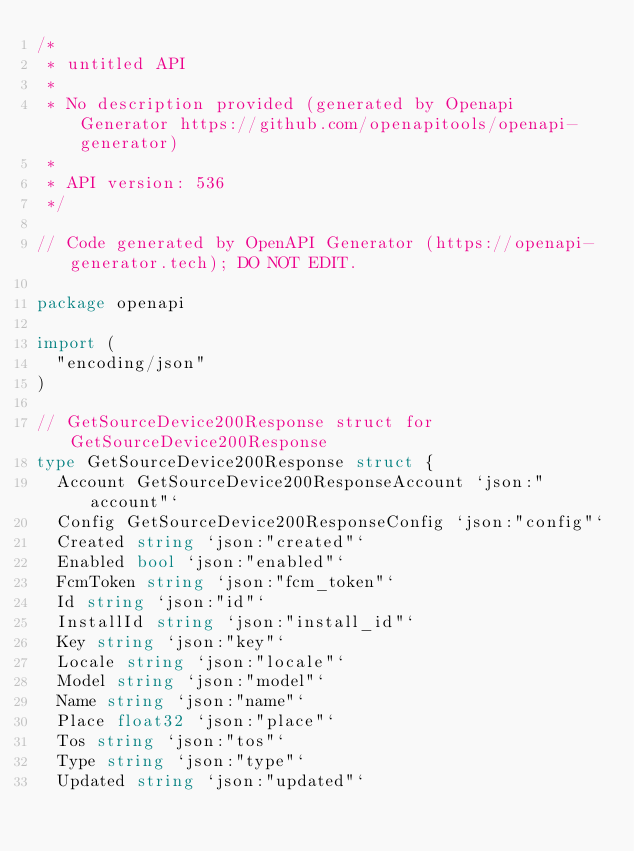Convert code to text. <code><loc_0><loc_0><loc_500><loc_500><_Go_>/*
 * untitled API
 *
 * No description provided (generated by Openapi Generator https://github.com/openapitools/openapi-generator)
 *
 * API version: 536
 */

// Code generated by OpenAPI Generator (https://openapi-generator.tech); DO NOT EDIT.

package openapi

import (
	"encoding/json"
)

// GetSourceDevice200Response struct for GetSourceDevice200Response
type GetSourceDevice200Response struct {
	Account GetSourceDevice200ResponseAccount `json:"account"`
	Config GetSourceDevice200ResponseConfig `json:"config"`
	Created string `json:"created"`
	Enabled bool `json:"enabled"`
	FcmToken string `json:"fcm_token"`
	Id string `json:"id"`
	InstallId string `json:"install_id"`
	Key string `json:"key"`
	Locale string `json:"locale"`
	Model string `json:"model"`
	Name string `json:"name"`
	Place float32 `json:"place"`
	Tos string `json:"tos"`
	Type string `json:"type"`
	Updated string `json:"updated"`</code> 